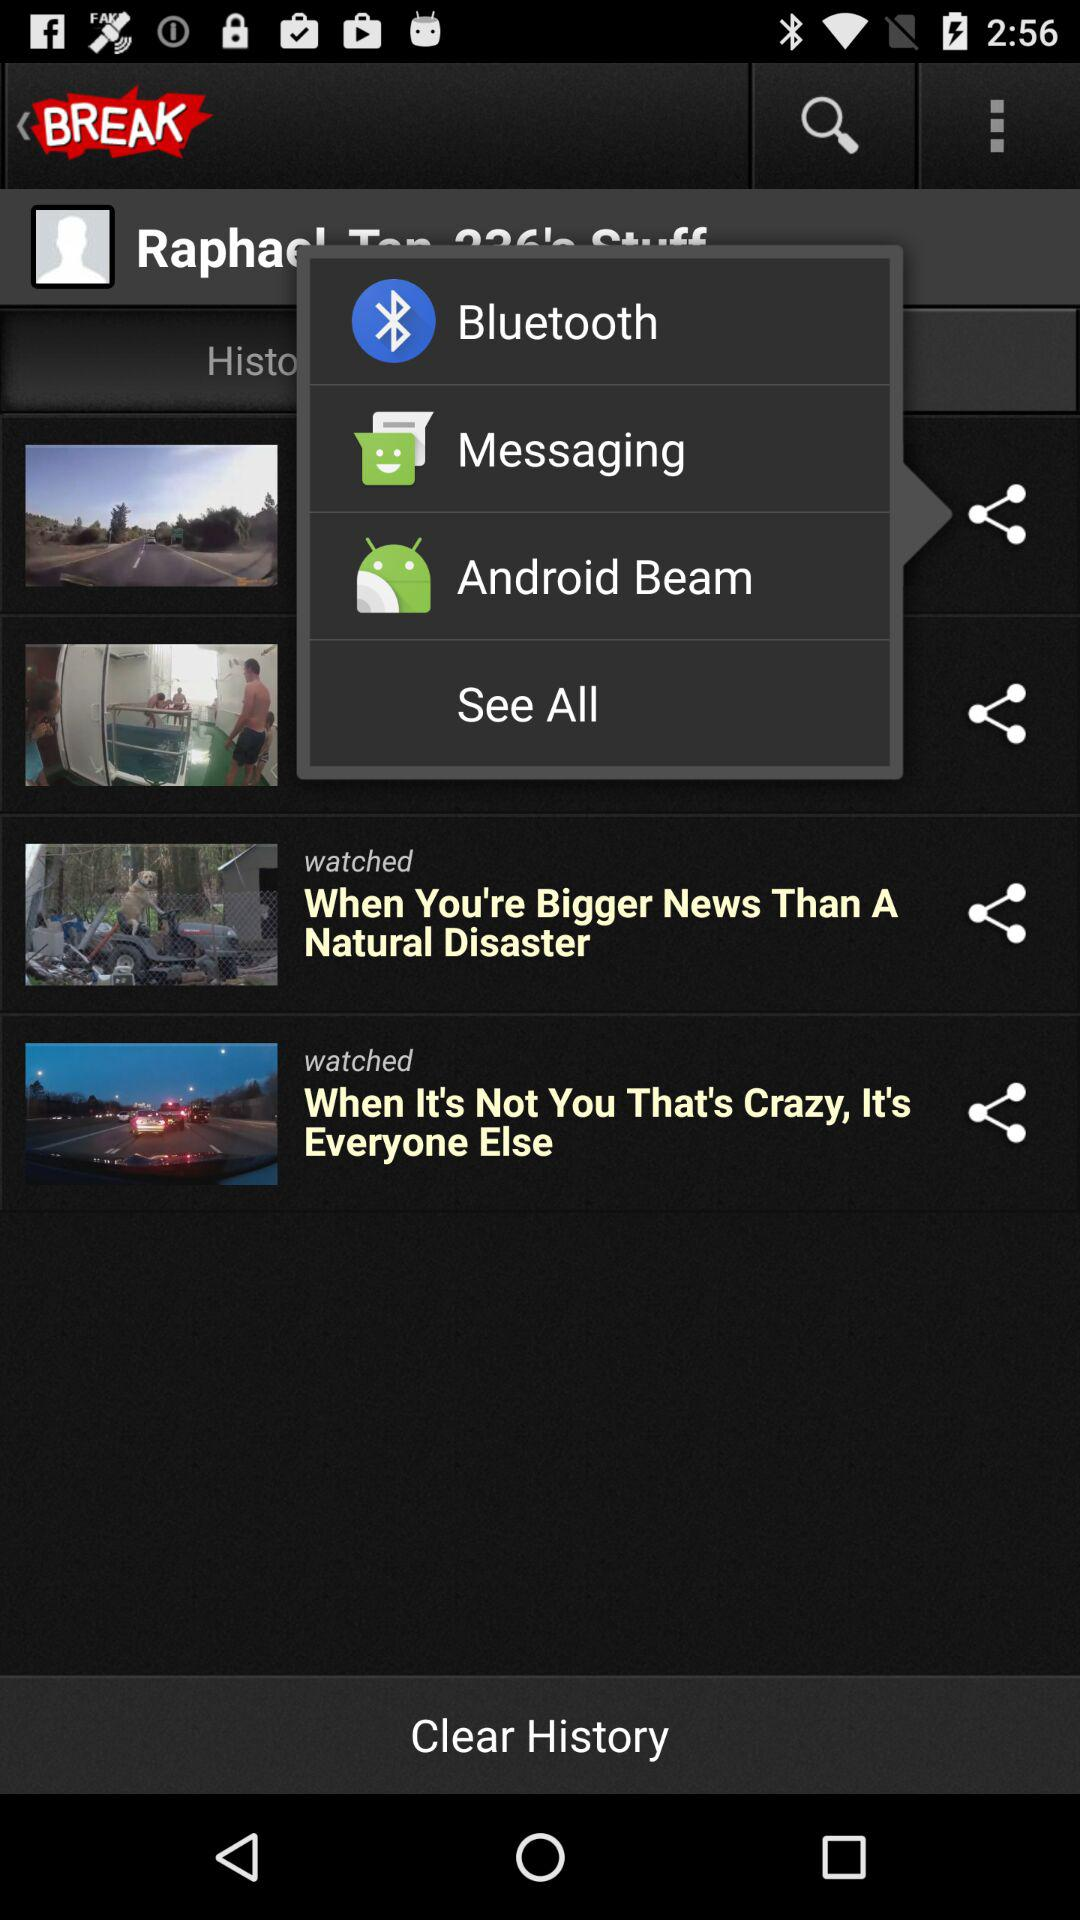What are the sharing options? The sharing options are "Bluetooth", "Messaging" and "Android Beam". 